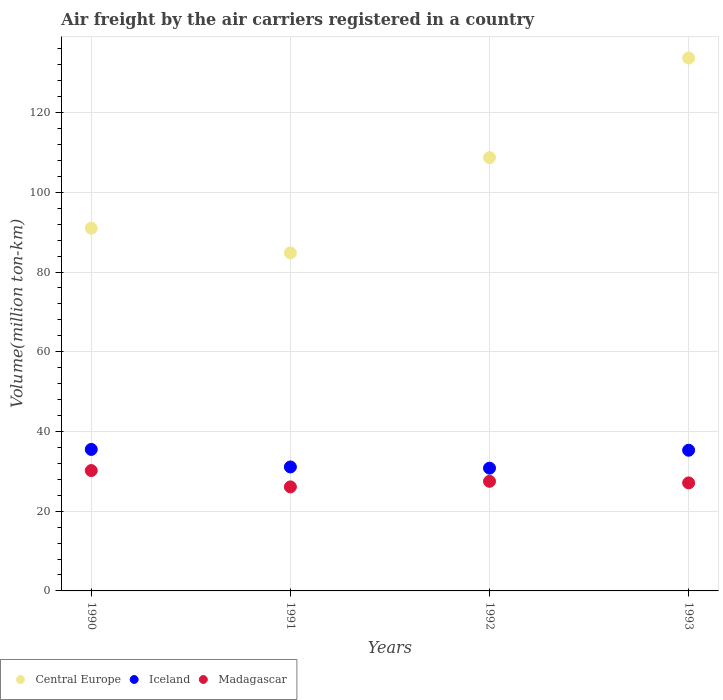What is the volume of the air carriers in Madagascar in 1991?
Offer a very short reply. 26.1. Across all years, what is the maximum volume of the air carriers in Iceland?
Your answer should be compact. 35.5. Across all years, what is the minimum volume of the air carriers in Madagascar?
Your response must be concise. 26.1. In which year was the volume of the air carriers in Iceland maximum?
Provide a succinct answer. 1990. What is the total volume of the air carriers in Iceland in the graph?
Provide a short and direct response. 132.7. What is the difference between the volume of the air carriers in Central Europe in 1990 and that in 1992?
Offer a terse response. -17.7. What is the difference between the volume of the air carriers in Central Europe in 1993 and the volume of the air carriers in Iceland in 1992?
Offer a very short reply. 102.9. What is the average volume of the air carriers in Iceland per year?
Your answer should be very brief. 33.17. In the year 1993, what is the difference between the volume of the air carriers in Iceland and volume of the air carriers in Central Europe?
Provide a succinct answer. -98.4. What is the ratio of the volume of the air carriers in Iceland in 1990 to that in 1992?
Offer a very short reply. 1.15. Is the volume of the air carriers in Iceland in 1991 less than that in 1993?
Your answer should be very brief. Yes. What is the difference between the highest and the second highest volume of the air carriers in Central Europe?
Your answer should be very brief. 25. What is the difference between the highest and the lowest volume of the air carriers in Central Europe?
Provide a succinct answer. 48.9. In how many years, is the volume of the air carriers in Central Europe greater than the average volume of the air carriers in Central Europe taken over all years?
Your response must be concise. 2. Is the sum of the volume of the air carriers in Central Europe in 1992 and 1993 greater than the maximum volume of the air carriers in Madagascar across all years?
Provide a succinct answer. Yes. Does the volume of the air carriers in Central Europe monotonically increase over the years?
Provide a short and direct response. No. Is the volume of the air carriers in Central Europe strictly greater than the volume of the air carriers in Iceland over the years?
Your response must be concise. Yes. Is the volume of the air carriers in Central Europe strictly less than the volume of the air carriers in Iceland over the years?
Keep it short and to the point. No. How many years are there in the graph?
Your answer should be compact. 4. What is the difference between two consecutive major ticks on the Y-axis?
Provide a succinct answer. 20. Are the values on the major ticks of Y-axis written in scientific E-notation?
Offer a terse response. No. Does the graph contain any zero values?
Offer a very short reply. No. Does the graph contain grids?
Keep it short and to the point. Yes. How are the legend labels stacked?
Your answer should be compact. Horizontal. What is the title of the graph?
Ensure brevity in your answer.  Air freight by the air carriers registered in a country. Does "East Asia (developing only)" appear as one of the legend labels in the graph?
Provide a short and direct response. No. What is the label or title of the X-axis?
Provide a short and direct response. Years. What is the label or title of the Y-axis?
Your answer should be very brief. Volume(million ton-km). What is the Volume(million ton-km) in Central Europe in 1990?
Give a very brief answer. 91. What is the Volume(million ton-km) of Iceland in 1990?
Offer a terse response. 35.5. What is the Volume(million ton-km) of Madagascar in 1990?
Provide a short and direct response. 30.2. What is the Volume(million ton-km) of Central Europe in 1991?
Keep it short and to the point. 84.8. What is the Volume(million ton-km) in Iceland in 1991?
Offer a very short reply. 31.1. What is the Volume(million ton-km) in Madagascar in 1991?
Ensure brevity in your answer.  26.1. What is the Volume(million ton-km) of Central Europe in 1992?
Your answer should be very brief. 108.7. What is the Volume(million ton-km) in Iceland in 1992?
Your answer should be compact. 30.8. What is the Volume(million ton-km) in Central Europe in 1993?
Give a very brief answer. 133.7. What is the Volume(million ton-km) of Iceland in 1993?
Provide a succinct answer. 35.3. What is the Volume(million ton-km) in Madagascar in 1993?
Give a very brief answer. 27.1. Across all years, what is the maximum Volume(million ton-km) of Central Europe?
Your response must be concise. 133.7. Across all years, what is the maximum Volume(million ton-km) of Iceland?
Ensure brevity in your answer.  35.5. Across all years, what is the maximum Volume(million ton-km) in Madagascar?
Ensure brevity in your answer.  30.2. Across all years, what is the minimum Volume(million ton-km) in Central Europe?
Your response must be concise. 84.8. Across all years, what is the minimum Volume(million ton-km) of Iceland?
Your answer should be compact. 30.8. Across all years, what is the minimum Volume(million ton-km) of Madagascar?
Provide a short and direct response. 26.1. What is the total Volume(million ton-km) of Central Europe in the graph?
Keep it short and to the point. 418.2. What is the total Volume(million ton-km) in Iceland in the graph?
Provide a succinct answer. 132.7. What is the total Volume(million ton-km) of Madagascar in the graph?
Your response must be concise. 110.9. What is the difference between the Volume(million ton-km) in Central Europe in 1990 and that in 1991?
Your answer should be compact. 6.2. What is the difference between the Volume(million ton-km) in Central Europe in 1990 and that in 1992?
Ensure brevity in your answer.  -17.7. What is the difference between the Volume(million ton-km) of Iceland in 1990 and that in 1992?
Provide a succinct answer. 4.7. What is the difference between the Volume(million ton-km) in Central Europe in 1990 and that in 1993?
Ensure brevity in your answer.  -42.7. What is the difference between the Volume(million ton-km) in Iceland in 1990 and that in 1993?
Your answer should be compact. 0.2. What is the difference between the Volume(million ton-km) in Madagascar in 1990 and that in 1993?
Offer a very short reply. 3.1. What is the difference between the Volume(million ton-km) in Central Europe in 1991 and that in 1992?
Provide a succinct answer. -23.9. What is the difference between the Volume(million ton-km) of Central Europe in 1991 and that in 1993?
Offer a very short reply. -48.9. What is the difference between the Volume(million ton-km) in Madagascar in 1991 and that in 1993?
Ensure brevity in your answer.  -1. What is the difference between the Volume(million ton-km) of Central Europe in 1992 and that in 1993?
Provide a succinct answer. -25. What is the difference between the Volume(million ton-km) of Iceland in 1992 and that in 1993?
Give a very brief answer. -4.5. What is the difference between the Volume(million ton-km) of Madagascar in 1992 and that in 1993?
Make the answer very short. 0.4. What is the difference between the Volume(million ton-km) of Central Europe in 1990 and the Volume(million ton-km) of Iceland in 1991?
Keep it short and to the point. 59.9. What is the difference between the Volume(million ton-km) in Central Europe in 1990 and the Volume(million ton-km) in Madagascar in 1991?
Keep it short and to the point. 64.9. What is the difference between the Volume(million ton-km) of Iceland in 1990 and the Volume(million ton-km) of Madagascar in 1991?
Offer a very short reply. 9.4. What is the difference between the Volume(million ton-km) in Central Europe in 1990 and the Volume(million ton-km) in Iceland in 1992?
Offer a terse response. 60.2. What is the difference between the Volume(million ton-km) of Central Europe in 1990 and the Volume(million ton-km) of Madagascar in 1992?
Provide a short and direct response. 63.5. What is the difference between the Volume(million ton-km) of Central Europe in 1990 and the Volume(million ton-km) of Iceland in 1993?
Provide a succinct answer. 55.7. What is the difference between the Volume(million ton-km) of Central Europe in 1990 and the Volume(million ton-km) of Madagascar in 1993?
Make the answer very short. 63.9. What is the difference between the Volume(million ton-km) in Iceland in 1990 and the Volume(million ton-km) in Madagascar in 1993?
Keep it short and to the point. 8.4. What is the difference between the Volume(million ton-km) of Central Europe in 1991 and the Volume(million ton-km) of Iceland in 1992?
Provide a succinct answer. 54. What is the difference between the Volume(million ton-km) in Central Europe in 1991 and the Volume(million ton-km) in Madagascar in 1992?
Offer a very short reply. 57.3. What is the difference between the Volume(million ton-km) in Iceland in 1991 and the Volume(million ton-km) in Madagascar in 1992?
Ensure brevity in your answer.  3.6. What is the difference between the Volume(million ton-km) in Central Europe in 1991 and the Volume(million ton-km) in Iceland in 1993?
Provide a short and direct response. 49.5. What is the difference between the Volume(million ton-km) in Central Europe in 1991 and the Volume(million ton-km) in Madagascar in 1993?
Make the answer very short. 57.7. What is the difference between the Volume(million ton-km) of Iceland in 1991 and the Volume(million ton-km) of Madagascar in 1993?
Your answer should be compact. 4. What is the difference between the Volume(million ton-km) in Central Europe in 1992 and the Volume(million ton-km) in Iceland in 1993?
Your answer should be compact. 73.4. What is the difference between the Volume(million ton-km) of Central Europe in 1992 and the Volume(million ton-km) of Madagascar in 1993?
Your response must be concise. 81.6. What is the average Volume(million ton-km) of Central Europe per year?
Provide a short and direct response. 104.55. What is the average Volume(million ton-km) in Iceland per year?
Give a very brief answer. 33.17. What is the average Volume(million ton-km) of Madagascar per year?
Offer a terse response. 27.73. In the year 1990, what is the difference between the Volume(million ton-km) in Central Europe and Volume(million ton-km) in Iceland?
Your answer should be very brief. 55.5. In the year 1990, what is the difference between the Volume(million ton-km) of Central Europe and Volume(million ton-km) of Madagascar?
Your answer should be compact. 60.8. In the year 1991, what is the difference between the Volume(million ton-km) of Central Europe and Volume(million ton-km) of Iceland?
Provide a short and direct response. 53.7. In the year 1991, what is the difference between the Volume(million ton-km) in Central Europe and Volume(million ton-km) in Madagascar?
Your response must be concise. 58.7. In the year 1992, what is the difference between the Volume(million ton-km) of Central Europe and Volume(million ton-km) of Iceland?
Ensure brevity in your answer.  77.9. In the year 1992, what is the difference between the Volume(million ton-km) in Central Europe and Volume(million ton-km) in Madagascar?
Offer a terse response. 81.2. In the year 1993, what is the difference between the Volume(million ton-km) in Central Europe and Volume(million ton-km) in Iceland?
Provide a short and direct response. 98.4. In the year 1993, what is the difference between the Volume(million ton-km) in Central Europe and Volume(million ton-km) in Madagascar?
Your answer should be compact. 106.6. What is the ratio of the Volume(million ton-km) in Central Europe in 1990 to that in 1991?
Keep it short and to the point. 1.07. What is the ratio of the Volume(million ton-km) of Iceland in 1990 to that in 1991?
Offer a very short reply. 1.14. What is the ratio of the Volume(million ton-km) of Madagascar in 1990 to that in 1991?
Offer a terse response. 1.16. What is the ratio of the Volume(million ton-km) of Central Europe in 1990 to that in 1992?
Your answer should be very brief. 0.84. What is the ratio of the Volume(million ton-km) of Iceland in 1990 to that in 1992?
Offer a terse response. 1.15. What is the ratio of the Volume(million ton-km) in Madagascar in 1990 to that in 1992?
Your answer should be very brief. 1.1. What is the ratio of the Volume(million ton-km) of Central Europe in 1990 to that in 1993?
Your response must be concise. 0.68. What is the ratio of the Volume(million ton-km) of Madagascar in 1990 to that in 1993?
Ensure brevity in your answer.  1.11. What is the ratio of the Volume(million ton-km) in Central Europe in 1991 to that in 1992?
Offer a very short reply. 0.78. What is the ratio of the Volume(million ton-km) in Iceland in 1991 to that in 1992?
Your answer should be very brief. 1.01. What is the ratio of the Volume(million ton-km) of Madagascar in 1991 to that in 1992?
Provide a short and direct response. 0.95. What is the ratio of the Volume(million ton-km) of Central Europe in 1991 to that in 1993?
Your answer should be compact. 0.63. What is the ratio of the Volume(million ton-km) of Iceland in 1991 to that in 1993?
Ensure brevity in your answer.  0.88. What is the ratio of the Volume(million ton-km) in Madagascar in 1991 to that in 1993?
Your answer should be very brief. 0.96. What is the ratio of the Volume(million ton-km) in Central Europe in 1992 to that in 1993?
Offer a very short reply. 0.81. What is the ratio of the Volume(million ton-km) in Iceland in 1992 to that in 1993?
Make the answer very short. 0.87. What is the ratio of the Volume(million ton-km) of Madagascar in 1992 to that in 1993?
Provide a short and direct response. 1.01. What is the difference between the highest and the lowest Volume(million ton-km) of Central Europe?
Provide a short and direct response. 48.9. What is the difference between the highest and the lowest Volume(million ton-km) of Iceland?
Make the answer very short. 4.7. 